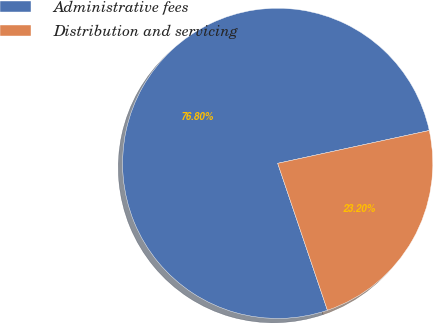<chart> <loc_0><loc_0><loc_500><loc_500><pie_chart><fcel>Administrative fees<fcel>Distribution and servicing<nl><fcel>76.8%<fcel>23.2%<nl></chart> 